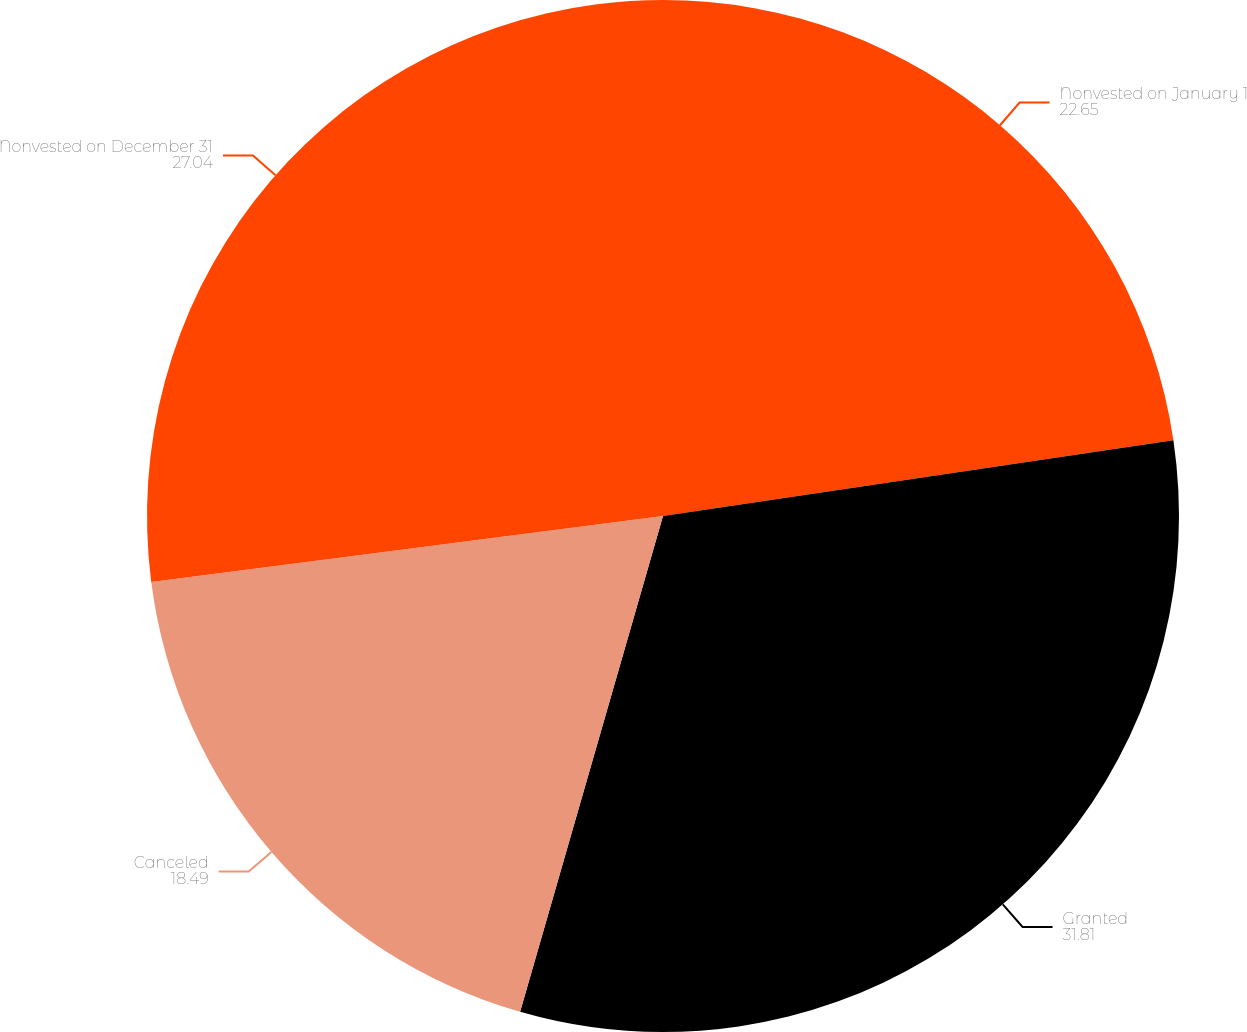Convert chart to OTSL. <chart><loc_0><loc_0><loc_500><loc_500><pie_chart><fcel>Nonvested on January 1<fcel>Granted<fcel>Canceled<fcel>Nonvested on December 31<nl><fcel>22.65%<fcel>31.81%<fcel>18.49%<fcel>27.04%<nl></chart> 